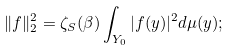<formula> <loc_0><loc_0><loc_500><loc_500>\| f \| ^ { 2 } _ { 2 } = \zeta _ { S } ( \beta ) \int _ { Y _ { 0 } } | f ( y ) | ^ { 2 } d \mu ( y ) ;</formula> 